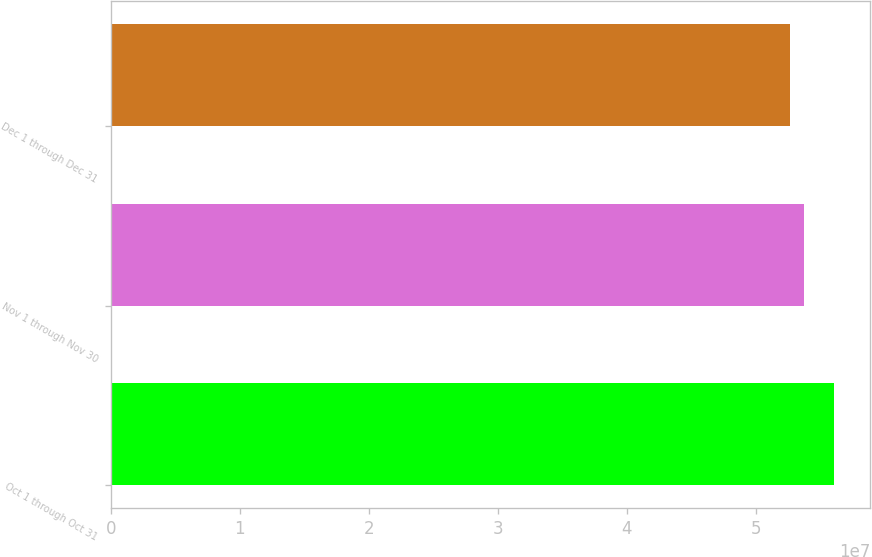Convert chart. <chart><loc_0><loc_0><loc_500><loc_500><bar_chart><fcel>Oct 1 through Oct 31<fcel>Nov 1 through Nov 30<fcel>Dec 1 through Dec 31<nl><fcel>5.60782e+07<fcel>5.37552e+07<fcel>5.26524e+07<nl></chart> 